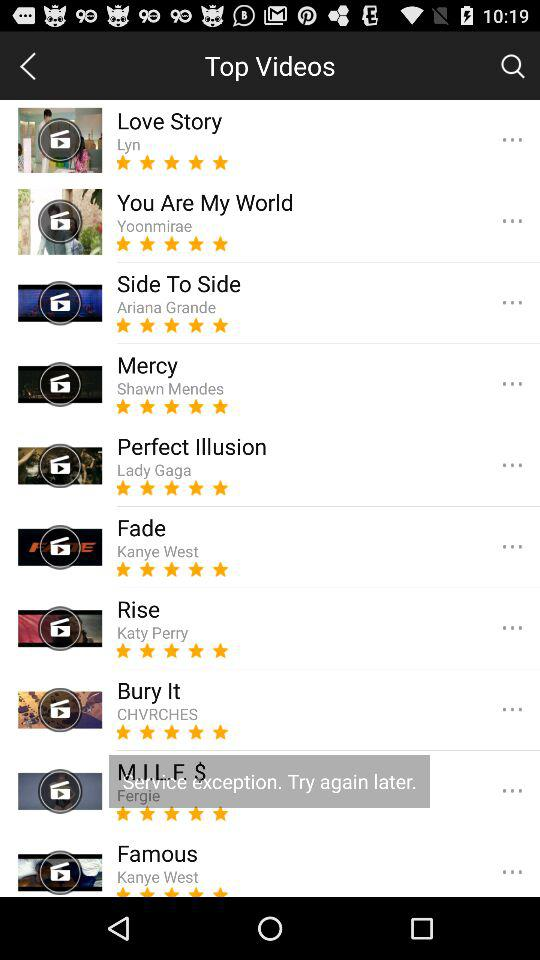Who is the singer of the song Fade? The singer of the song Fade is "Kanye West". 